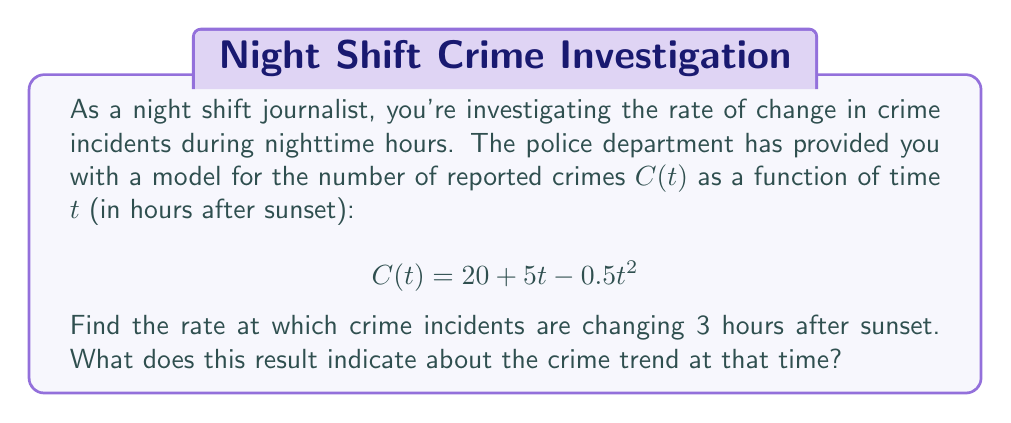Help me with this question. To solve this problem, we need to find the rate of change of the crime incidents function at a specific time. This rate of change is represented by the derivative of the function $C(t)$ with respect to $t$.

1) First, let's find the derivative of $C(t)$:
   
   $$\frac{dC}{dt} = \frac{d}{dt}(20 + 5t - 0.5t^2)$$
   
   Using the power rule and constant rule of differentiation:
   
   $$\frac{dC}{dt} = 0 + 5 - 0.5(2t) = 5 - t$$

2) Now that we have the rate of change function, we need to evaluate it at $t = 3$ (3 hours after sunset):

   $$\frac{dC}{dt}\bigg|_{t=3} = 5 - 3 = 2$$

3) Interpreting the result:
   The rate of change at 3 hours after sunset is 2 crimes per hour. This positive value indicates that crime incidents are still increasing at this time, but at a slower rate than initially (when the rate was 5 crimes per hour at $t = 0$).

4) We can also note that the rate of change is decreasing over time (as the derivative is a decreasing linear function). The crime rate will eventually start decreasing when $\frac{dC}{dt} = 0$, which occurs at $t = 5$ hours after sunset.
Answer: The rate of change in crime incidents 3 hours after sunset is 2 crimes per hour, indicating that crime is still increasing but at a diminishing rate. 